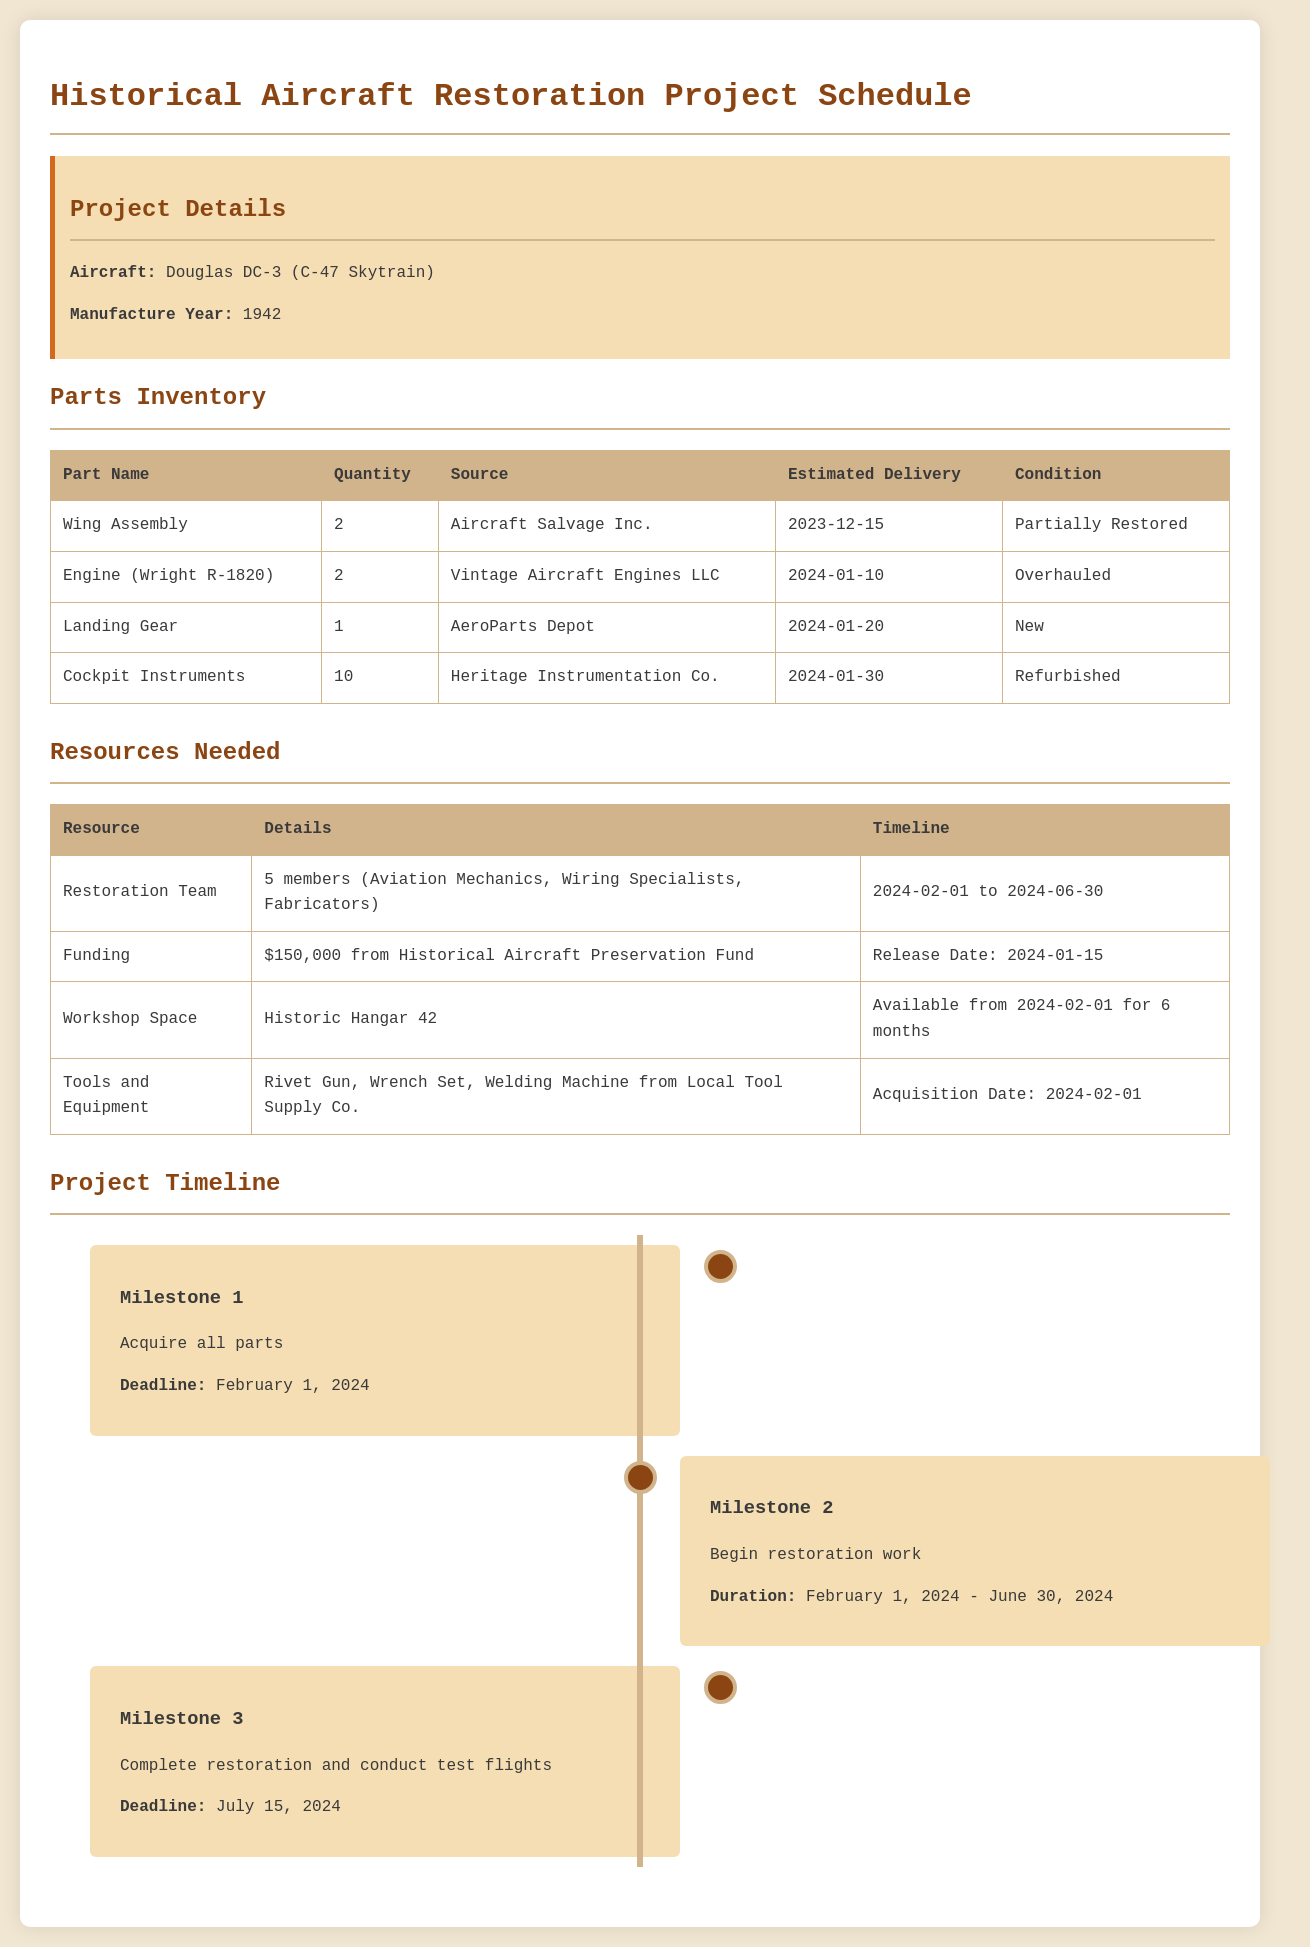What is the aircraft type? The document specifies that the aircraft is the Douglas DC-3 (C-47 Skytrain).
Answer: Douglas DC-3 (C-47 Skytrain) How many engines are needed? There are 2 engines required according to the parts inventory.
Answer: 2 What is the delivery date for the Cockpit Instruments? The estimated delivery date for Cockpit Instruments is provided in the inventory section.
Answer: 2024-01-30 When does the restoration team timeline start? The document states that the restoration team will be available starting February 1, 2024.
Answer: 2024-02-01 What is the total funding amount for the project? The document mentions that $150,000 is allocated from the Historical Aircraft Preservation Fund.
Answer: $150,000 Which company provides the Wing Assembly? The source for the Wing Assembly is mentioned as Aircraft Salvage Inc.
Answer: Aircraft Salvage Inc What is the deadline for acquiring all parts? The deadline to acquire all parts is specified in the milestone section.
Answer: February 1, 2024 How long will the workshop space be available? The document indicates the workshop space will be available for 6 months starting from February 1, 2024.
Answer: 6 months What is the condition of the Landing Gear? The parts inventory lists the condition of the Landing Gear.
Answer: New 